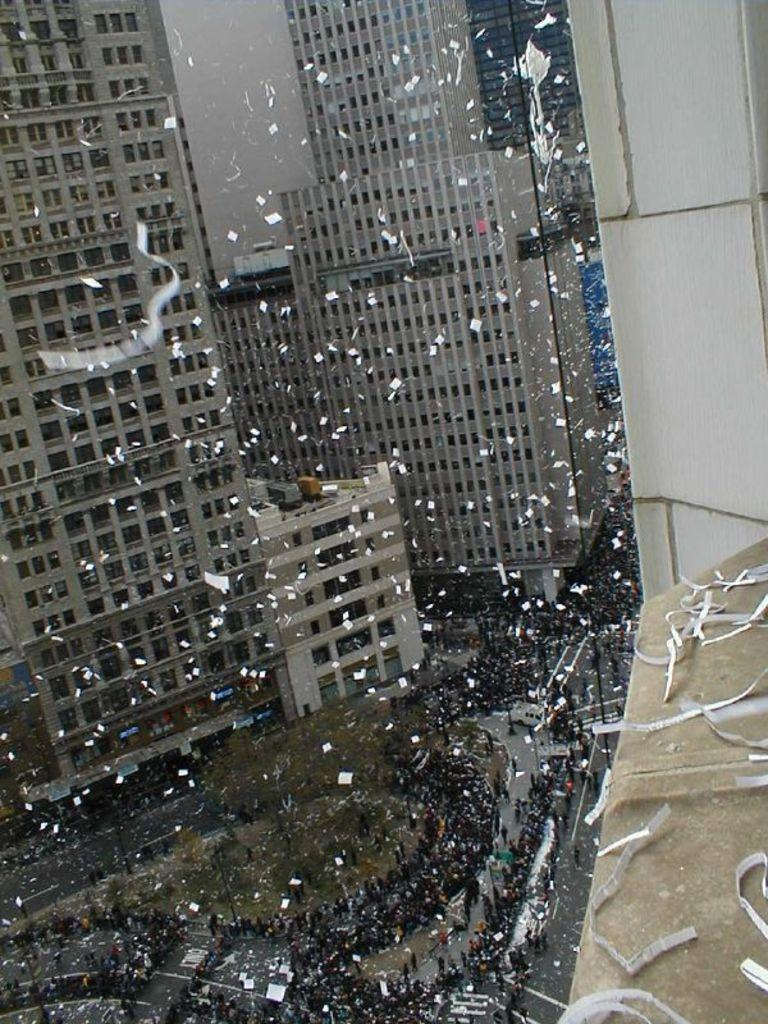What type of structures can be seen in the image? There are buildings in the image. What is happening with the papers in the image? Papers are flying in the air in the image. What type of vegetation is present in the image? There are trees in the image. How are the people in the image positioned? There is a group of people on roads in the image. Can you describe any other objects in the image? There are some objects in the image. What verse is being recited by the trees in the image? There is no verse being recited by the trees in the image, as trees do not have the ability to recite verses. What time of day is depicted in the image? The provided facts do not give any information about the time of day, so it cannot be determined from the image. 